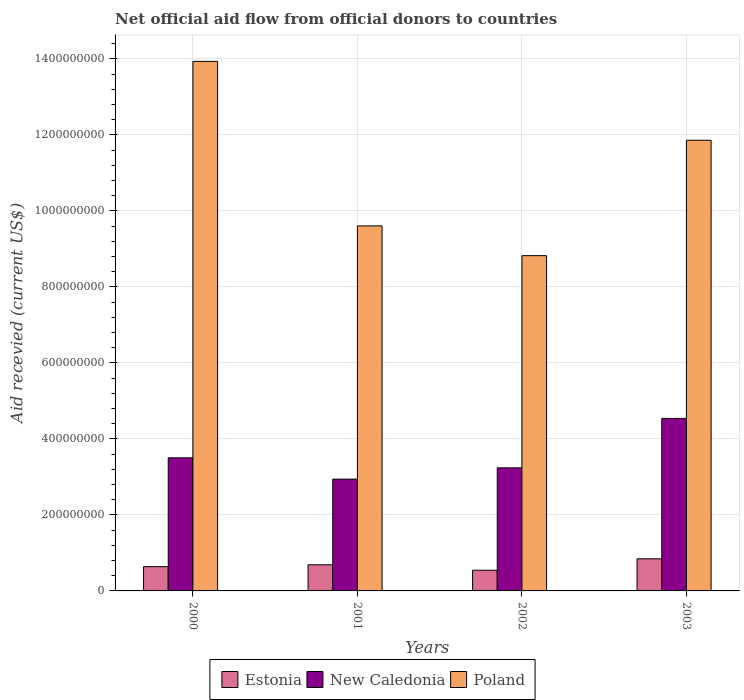How many different coloured bars are there?
Your answer should be compact. 3. Are the number of bars on each tick of the X-axis equal?
Provide a succinct answer. Yes. In how many cases, is the number of bars for a given year not equal to the number of legend labels?
Ensure brevity in your answer.  0. What is the total aid received in Estonia in 2002?
Your answer should be very brief. 5.44e+07. Across all years, what is the maximum total aid received in Estonia?
Your response must be concise. 8.45e+07. Across all years, what is the minimum total aid received in Estonia?
Your answer should be compact. 5.44e+07. In which year was the total aid received in New Caledonia minimum?
Keep it short and to the point. 2001. What is the total total aid received in Estonia in the graph?
Keep it short and to the point. 2.72e+08. What is the difference between the total aid received in New Caledonia in 2001 and that in 2002?
Your answer should be compact. -2.97e+07. What is the difference between the total aid received in Estonia in 2000 and the total aid received in Poland in 2003?
Give a very brief answer. -1.12e+09. What is the average total aid received in Poland per year?
Provide a short and direct response. 1.11e+09. In the year 2003, what is the difference between the total aid received in Estonia and total aid received in Poland?
Your answer should be very brief. -1.10e+09. In how many years, is the total aid received in New Caledonia greater than 1320000000 US$?
Provide a succinct answer. 0. What is the ratio of the total aid received in New Caledonia in 2000 to that in 2002?
Make the answer very short. 1.08. Is the difference between the total aid received in Estonia in 2000 and 2001 greater than the difference between the total aid received in Poland in 2000 and 2001?
Offer a very short reply. No. What is the difference between the highest and the second highest total aid received in New Caledonia?
Your response must be concise. 1.04e+08. What is the difference between the highest and the lowest total aid received in New Caledonia?
Keep it short and to the point. 1.60e+08. In how many years, is the total aid received in New Caledonia greater than the average total aid received in New Caledonia taken over all years?
Keep it short and to the point. 1. What does the 3rd bar from the left in 2003 represents?
Provide a succinct answer. Poland. How many bars are there?
Your answer should be very brief. 12. How many years are there in the graph?
Offer a terse response. 4. What is the difference between two consecutive major ticks on the Y-axis?
Provide a succinct answer. 2.00e+08. Are the values on the major ticks of Y-axis written in scientific E-notation?
Provide a short and direct response. No. Does the graph contain any zero values?
Provide a succinct answer. No. Does the graph contain grids?
Make the answer very short. Yes. How many legend labels are there?
Your answer should be very brief. 3. What is the title of the graph?
Offer a very short reply. Net official aid flow from official donors to countries. Does "Brunei Darussalam" appear as one of the legend labels in the graph?
Make the answer very short. No. What is the label or title of the X-axis?
Your answer should be compact. Years. What is the label or title of the Y-axis?
Your answer should be compact. Aid recevied (current US$). What is the Aid recevied (current US$) of Estonia in 2000?
Your answer should be very brief. 6.38e+07. What is the Aid recevied (current US$) in New Caledonia in 2000?
Provide a succinct answer. 3.50e+08. What is the Aid recevied (current US$) of Poland in 2000?
Offer a very short reply. 1.39e+09. What is the Aid recevied (current US$) in Estonia in 2001?
Give a very brief answer. 6.88e+07. What is the Aid recevied (current US$) of New Caledonia in 2001?
Your response must be concise. 2.94e+08. What is the Aid recevied (current US$) of Poland in 2001?
Your answer should be very brief. 9.60e+08. What is the Aid recevied (current US$) of Estonia in 2002?
Ensure brevity in your answer.  5.44e+07. What is the Aid recevied (current US$) of New Caledonia in 2002?
Make the answer very short. 3.24e+08. What is the Aid recevied (current US$) in Poland in 2002?
Your answer should be very brief. 8.82e+08. What is the Aid recevied (current US$) in Estonia in 2003?
Provide a short and direct response. 8.45e+07. What is the Aid recevied (current US$) of New Caledonia in 2003?
Keep it short and to the point. 4.54e+08. What is the Aid recevied (current US$) in Poland in 2003?
Your answer should be compact. 1.19e+09. Across all years, what is the maximum Aid recevied (current US$) of Estonia?
Offer a terse response. 8.45e+07. Across all years, what is the maximum Aid recevied (current US$) in New Caledonia?
Ensure brevity in your answer.  4.54e+08. Across all years, what is the maximum Aid recevied (current US$) of Poland?
Ensure brevity in your answer.  1.39e+09. Across all years, what is the minimum Aid recevied (current US$) of Estonia?
Provide a succinct answer. 5.44e+07. Across all years, what is the minimum Aid recevied (current US$) in New Caledonia?
Ensure brevity in your answer.  2.94e+08. Across all years, what is the minimum Aid recevied (current US$) of Poland?
Make the answer very short. 8.82e+08. What is the total Aid recevied (current US$) of Estonia in the graph?
Ensure brevity in your answer.  2.72e+08. What is the total Aid recevied (current US$) of New Caledonia in the graph?
Offer a very short reply. 1.42e+09. What is the total Aid recevied (current US$) in Poland in the graph?
Your answer should be very brief. 4.42e+09. What is the difference between the Aid recevied (current US$) of Estonia in 2000 and that in 2001?
Keep it short and to the point. -4.95e+06. What is the difference between the Aid recevied (current US$) in New Caledonia in 2000 and that in 2001?
Your answer should be very brief. 5.60e+07. What is the difference between the Aid recevied (current US$) of Poland in 2000 and that in 2001?
Offer a very short reply. 4.33e+08. What is the difference between the Aid recevied (current US$) of Estonia in 2000 and that in 2002?
Keep it short and to the point. 9.42e+06. What is the difference between the Aid recevied (current US$) of New Caledonia in 2000 and that in 2002?
Your answer should be very brief. 2.63e+07. What is the difference between the Aid recevied (current US$) in Poland in 2000 and that in 2002?
Provide a short and direct response. 5.11e+08. What is the difference between the Aid recevied (current US$) of Estonia in 2000 and that in 2003?
Keep it short and to the point. -2.07e+07. What is the difference between the Aid recevied (current US$) of New Caledonia in 2000 and that in 2003?
Offer a very short reply. -1.04e+08. What is the difference between the Aid recevied (current US$) in Poland in 2000 and that in 2003?
Provide a succinct answer. 2.08e+08. What is the difference between the Aid recevied (current US$) of Estonia in 2001 and that in 2002?
Offer a very short reply. 1.44e+07. What is the difference between the Aid recevied (current US$) in New Caledonia in 2001 and that in 2002?
Your response must be concise. -2.97e+07. What is the difference between the Aid recevied (current US$) of Poland in 2001 and that in 2002?
Offer a terse response. 7.83e+07. What is the difference between the Aid recevied (current US$) in Estonia in 2001 and that in 2003?
Make the answer very short. -1.57e+07. What is the difference between the Aid recevied (current US$) of New Caledonia in 2001 and that in 2003?
Provide a succinct answer. -1.60e+08. What is the difference between the Aid recevied (current US$) of Poland in 2001 and that in 2003?
Give a very brief answer. -2.25e+08. What is the difference between the Aid recevied (current US$) in Estonia in 2002 and that in 2003?
Offer a terse response. -3.01e+07. What is the difference between the Aid recevied (current US$) of New Caledonia in 2002 and that in 2003?
Ensure brevity in your answer.  -1.30e+08. What is the difference between the Aid recevied (current US$) in Poland in 2002 and that in 2003?
Your answer should be compact. -3.04e+08. What is the difference between the Aid recevied (current US$) in Estonia in 2000 and the Aid recevied (current US$) in New Caledonia in 2001?
Your answer should be very brief. -2.30e+08. What is the difference between the Aid recevied (current US$) of Estonia in 2000 and the Aid recevied (current US$) of Poland in 2001?
Your answer should be compact. -8.97e+08. What is the difference between the Aid recevied (current US$) of New Caledonia in 2000 and the Aid recevied (current US$) of Poland in 2001?
Your response must be concise. -6.10e+08. What is the difference between the Aid recevied (current US$) in Estonia in 2000 and the Aid recevied (current US$) in New Caledonia in 2002?
Provide a succinct answer. -2.60e+08. What is the difference between the Aid recevied (current US$) in Estonia in 2000 and the Aid recevied (current US$) in Poland in 2002?
Provide a succinct answer. -8.18e+08. What is the difference between the Aid recevied (current US$) in New Caledonia in 2000 and the Aid recevied (current US$) in Poland in 2002?
Your answer should be very brief. -5.32e+08. What is the difference between the Aid recevied (current US$) in Estonia in 2000 and the Aid recevied (current US$) in New Caledonia in 2003?
Ensure brevity in your answer.  -3.90e+08. What is the difference between the Aid recevied (current US$) in Estonia in 2000 and the Aid recevied (current US$) in Poland in 2003?
Provide a succinct answer. -1.12e+09. What is the difference between the Aid recevied (current US$) of New Caledonia in 2000 and the Aid recevied (current US$) of Poland in 2003?
Give a very brief answer. -8.36e+08. What is the difference between the Aid recevied (current US$) in Estonia in 2001 and the Aid recevied (current US$) in New Caledonia in 2002?
Your answer should be compact. -2.55e+08. What is the difference between the Aid recevied (current US$) of Estonia in 2001 and the Aid recevied (current US$) of Poland in 2002?
Make the answer very short. -8.13e+08. What is the difference between the Aid recevied (current US$) in New Caledonia in 2001 and the Aid recevied (current US$) in Poland in 2002?
Give a very brief answer. -5.88e+08. What is the difference between the Aid recevied (current US$) in Estonia in 2001 and the Aid recevied (current US$) in New Caledonia in 2003?
Your answer should be compact. -3.85e+08. What is the difference between the Aid recevied (current US$) of Estonia in 2001 and the Aid recevied (current US$) of Poland in 2003?
Give a very brief answer. -1.12e+09. What is the difference between the Aid recevied (current US$) of New Caledonia in 2001 and the Aid recevied (current US$) of Poland in 2003?
Provide a short and direct response. -8.92e+08. What is the difference between the Aid recevied (current US$) in Estonia in 2002 and the Aid recevied (current US$) in New Caledonia in 2003?
Provide a succinct answer. -3.99e+08. What is the difference between the Aid recevied (current US$) of Estonia in 2002 and the Aid recevied (current US$) of Poland in 2003?
Your answer should be compact. -1.13e+09. What is the difference between the Aid recevied (current US$) in New Caledonia in 2002 and the Aid recevied (current US$) in Poland in 2003?
Offer a very short reply. -8.62e+08. What is the average Aid recevied (current US$) of Estonia per year?
Give a very brief answer. 6.79e+07. What is the average Aid recevied (current US$) of New Caledonia per year?
Offer a terse response. 3.56e+08. What is the average Aid recevied (current US$) of Poland per year?
Offer a terse response. 1.11e+09. In the year 2000, what is the difference between the Aid recevied (current US$) in Estonia and Aid recevied (current US$) in New Caledonia?
Provide a succinct answer. -2.86e+08. In the year 2000, what is the difference between the Aid recevied (current US$) in Estonia and Aid recevied (current US$) in Poland?
Offer a very short reply. -1.33e+09. In the year 2000, what is the difference between the Aid recevied (current US$) in New Caledonia and Aid recevied (current US$) in Poland?
Your answer should be compact. -1.04e+09. In the year 2001, what is the difference between the Aid recevied (current US$) of Estonia and Aid recevied (current US$) of New Caledonia?
Keep it short and to the point. -2.25e+08. In the year 2001, what is the difference between the Aid recevied (current US$) of Estonia and Aid recevied (current US$) of Poland?
Offer a very short reply. -8.92e+08. In the year 2001, what is the difference between the Aid recevied (current US$) in New Caledonia and Aid recevied (current US$) in Poland?
Your response must be concise. -6.66e+08. In the year 2002, what is the difference between the Aid recevied (current US$) in Estonia and Aid recevied (current US$) in New Caledonia?
Make the answer very short. -2.69e+08. In the year 2002, what is the difference between the Aid recevied (current US$) in Estonia and Aid recevied (current US$) in Poland?
Offer a very short reply. -8.28e+08. In the year 2002, what is the difference between the Aid recevied (current US$) of New Caledonia and Aid recevied (current US$) of Poland?
Offer a terse response. -5.58e+08. In the year 2003, what is the difference between the Aid recevied (current US$) of Estonia and Aid recevied (current US$) of New Caledonia?
Make the answer very short. -3.69e+08. In the year 2003, what is the difference between the Aid recevied (current US$) in Estonia and Aid recevied (current US$) in Poland?
Give a very brief answer. -1.10e+09. In the year 2003, what is the difference between the Aid recevied (current US$) of New Caledonia and Aid recevied (current US$) of Poland?
Your response must be concise. -7.32e+08. What is the ratio of the Aid recevied (current US$) of Estonia in 2000 to that in 2001?
Make the answer very short. 0.93. What is the ratio of the Aid recevied (current US$) of New Caledonia in 2000 to that in 2001?
Ensure brevity in your answer.  1.19. What is the ratio of the Aid recevied (current US$) of Poland in 2000 to that in 2001?
Offer a very short reply. 1.45. What is the ratio of the Aid recevied (current US$) in Estonia in 2000 to that in 2002?
Your answer should be compact. 1.17. What is the ratio of the Aid recevied (current US$) in New Caledonia in 2000 to that in 2002?
Offer a very short reply. 1.08. What is the ratio of the Aid recevied (current US$) of Poland in 2000 to that in 2002?
Your answer should be very brief. 1.58. What is the ratio of the Aid recevied (current US$) of Estonia in 2000 to that in 2003?
Ensure brevity in your answer.  0.76. What is the ratio of the Aid recevied (current US$) of New Caledonia in 2000 to that in 2003?
Provide a short and direct response. 0.77. What is the ratio of the Aid recevied (current US$) in Poland in 2000 to that in 2003?
Your answer should be very brief. 1.18. What is the ratio of the Aid recevied (current US$) in Estonia in 2001 to that in 2002?
Ensure brevity in your answer.  1.26. What is the ratio of the Aid recevied (current US$) in New Caledonia in 2001 to that in 2002?
Offer a terse response. 0.91. What is the ratio of the Aid recevied (current US$) of Poland in 2001 to that in 2002?
Your answer should be compact. 1.09. What is the ratio of the Aid recevied (current US$) of Estonia in 2001 to that in 2003?
Offer a very short reply. 0.81. What is the ratio of the Aid recevied (current US$) in New Caledonia in 2001 to that in 2003?
Your response must be concise. 0.65. What is the ratio of the Aid recevied (current US$) of Poland in 2001 to that in 2003?
Your answer should be compact. 0.81. What is the ratio of the Aid recevied (current US$) of Estonia in 2002 to that in 2003?
Your response must be concise. 0.64. What is the ratio of the Aid recevied (current US$) of New Caledonia in 2002 to that in 2003?
Your answer should be compact. 0.71. What is the ratio of the Aid recevied (current US$) in Poland in 2002 to that in 2003?
Offer a very short reply. 0.74. What is the difference between the highest and the second highest Aid recevied (current US$) of Estonia?
Ensure brevity in your answer.  1.57e+07. What is the difference between the highest and the second highest Aid recevied (current US$) of New Caledonia?
Your response must be concise. 1.04e+08. What is the difference between the highest and the second highest Aid recevied (current US$) in Poland?
Ensure brevity in your answer.  2.08e+08. What is the difference between the highest and the lowest Aid recevied (current US$) of Estonia?
Ensure brevity in your answer.  3.01e+07. What is the difference between the highest and the lowest Aid recevied (current US$) in New Caledonia?
Your response must be concise. 1.60e+08. What is the difference between the highest and the lowest Aid recevied (current US$) of Poland?
Your response must be concise. 5.11e+08. 